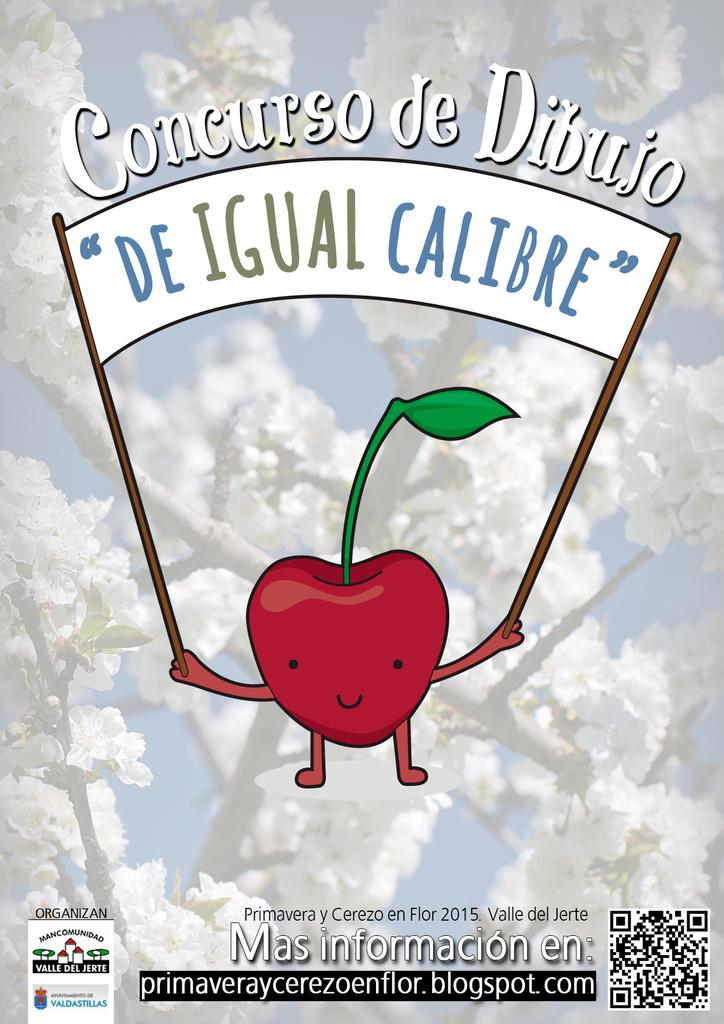What is the main subject of the picture? The main subject of the picture is an apple. What makes this apple different from a real apple? This apple has legs and hands, which are not typical features of real apples. What is the apple holding in the picture? The apple is holding a banner. What can be seen in the background of the image? There is a group of flowers in the background of the image. What type of stew is being prepared in the background of the image? There is no stew present in the image; it features an apple with legs and hands holding a banner, with a group of flowers in the background. Can you tell me the age of the girl in the image? There is no girl present in the image; it features an apple with legs and hands holding a banner, with a group of flowers in the background. 